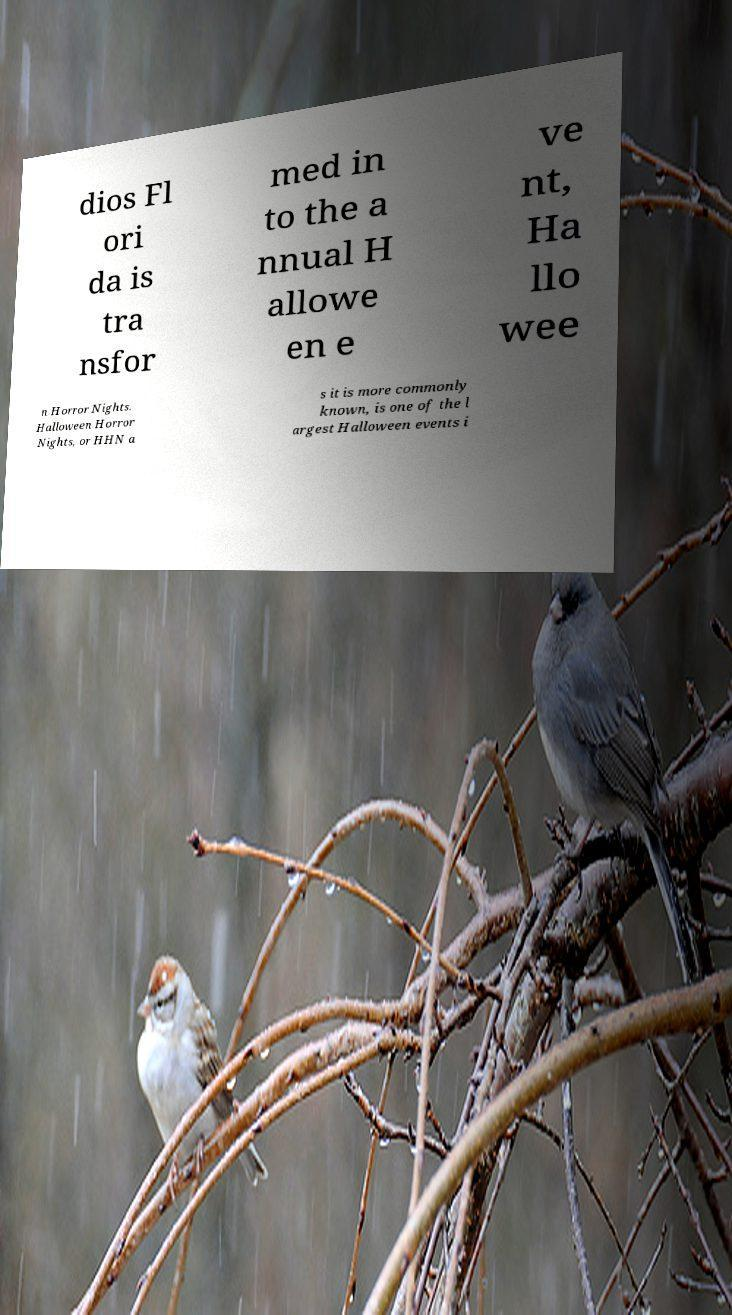Could you extract and type out the text from this image? dios Fl ori da is tra nsfor med in to the a nnual H allowe en e ve nt, Ha llo wee n Horror Nights. Halloween Horror Nights, or HHN a s it is more commonly known, is one of the l argest Halloween events i 